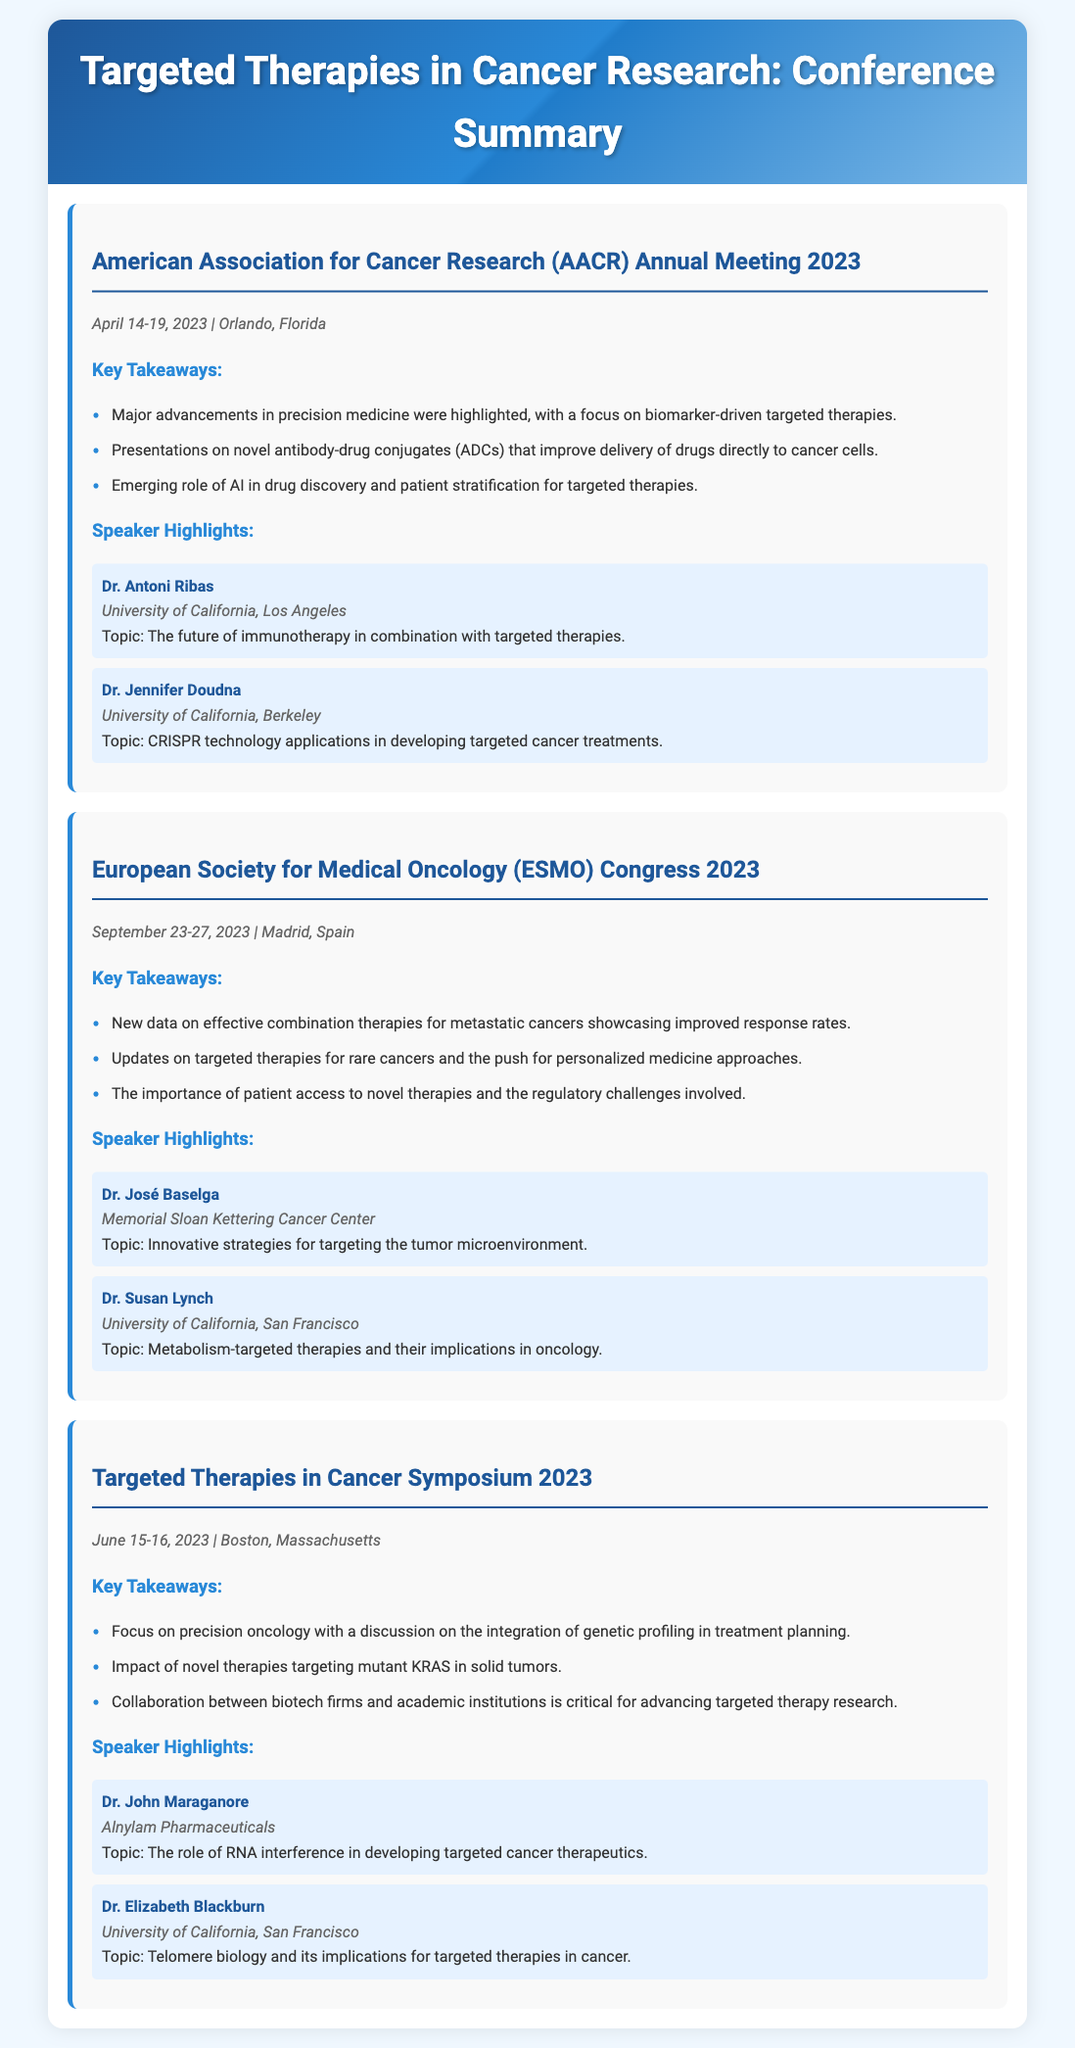what was the date of the AACR Annual Meeting 2023? The AACR Annual Meeting 2023 took place from April 14-19, 2023.
Answer: April 14-19, 2023 who spoke about the future of immunotherapy? Dr. Antoni Ribas of the University of California, Los Angeles was the speaker on this topic.
Answer: Dr. Antoni Ribas what was a key takeaway from the ESMO Congress 2023? One major takeaway was updates on targeted therapies for rare cancers.
Answer: targeted therapies for rare cancers which researcher discussed RNA interference at the Targeted Therapies in Cancer Symposium? Dr. John Maraganore from Alnylam Pharmaceuticals spoke on this subject.
Answer: Dr. John Maraganore how many notable conferences are summarized in the document? The document summarizes three notable cancer research conferences.
Answer: three what technology did Dr. Jennifer Doudna focus on? Dr. Jennifer Doudna highlighted CRISPR technology in her presentation.
Answer: CRISPR technology what was the location of the Targeted Therapies in Cancer Symposium 2023? The symposium took place in Boston, Massachusetts.
Answer: Boston, Massachusetts who discussed metabolism-targeted therapies? Dr. Susan Lynch from the University of California, San Francisco discussed this topic.
Answer: Dr. Susan Lynch 